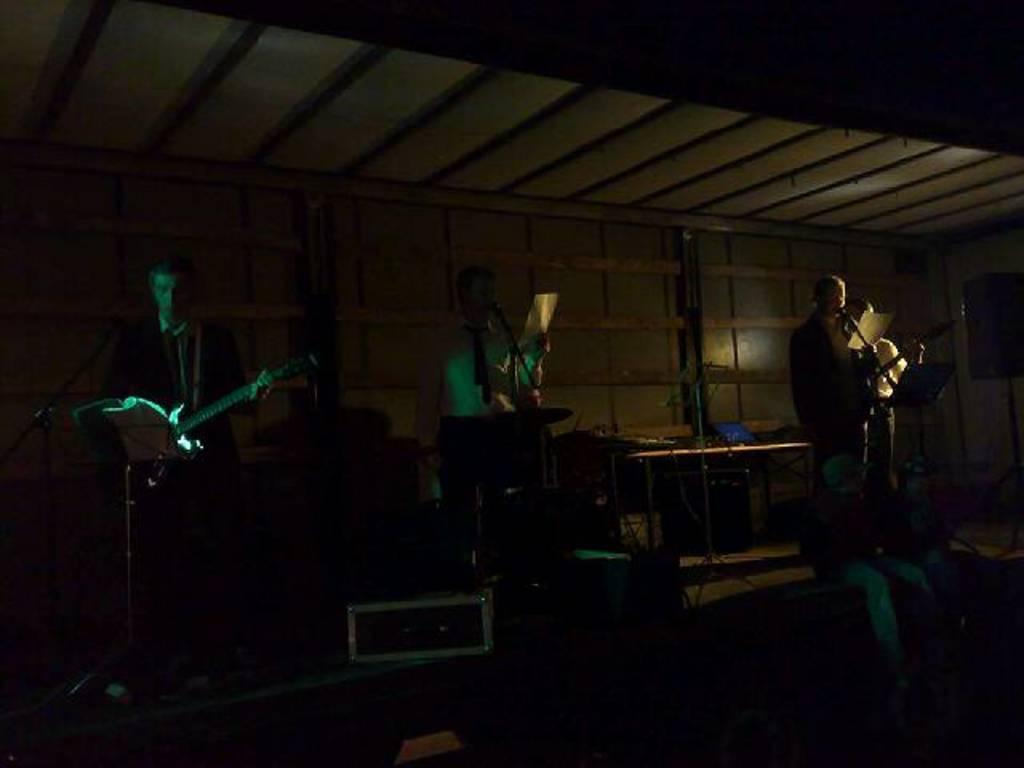Could you give a brief overview of what you see in this image? In this image I can see few people are standing. I can see few of them are holding musical instruments and rest are holding papers. Here I can see a mic. This image is completely in dark. 